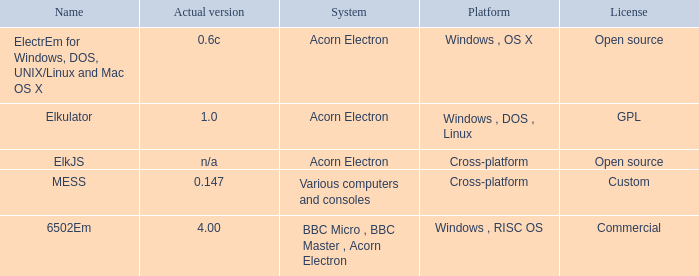What is the name of the platform used for various computers and consoles? Cross-platform. 